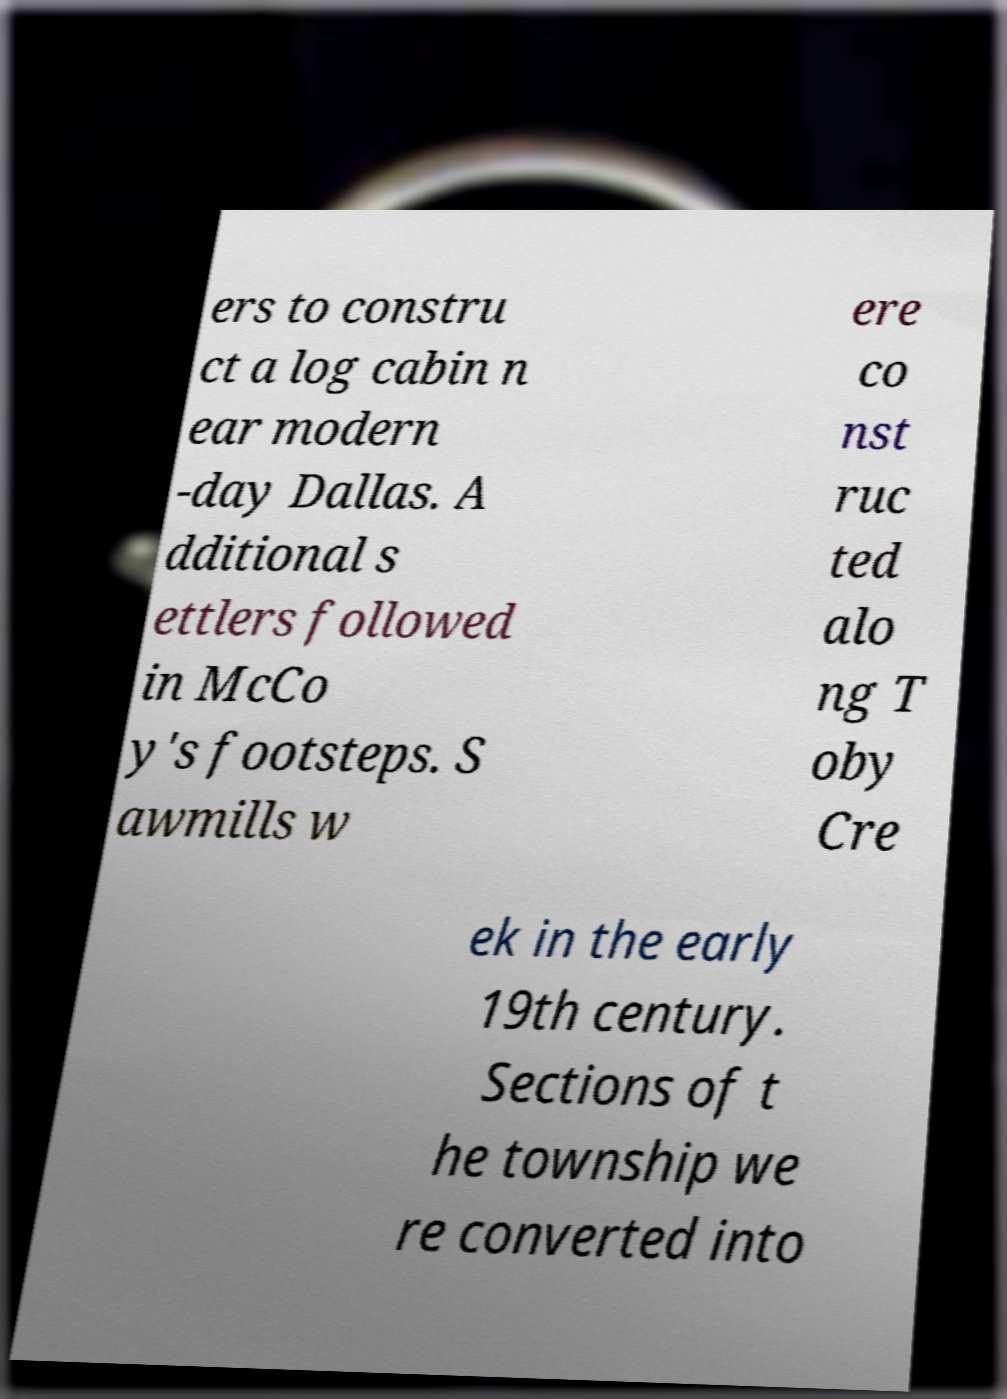Could you extract and type out the text from this image? ers to constru ct a log cabin n ear modern -day Dallas. A dditional s ettlers followed in McCo y's footsteps. S awmills w ere co nst ruc ted alo ng T oby Cre ek in the early 19th century. Sections of t he township we re converted into 